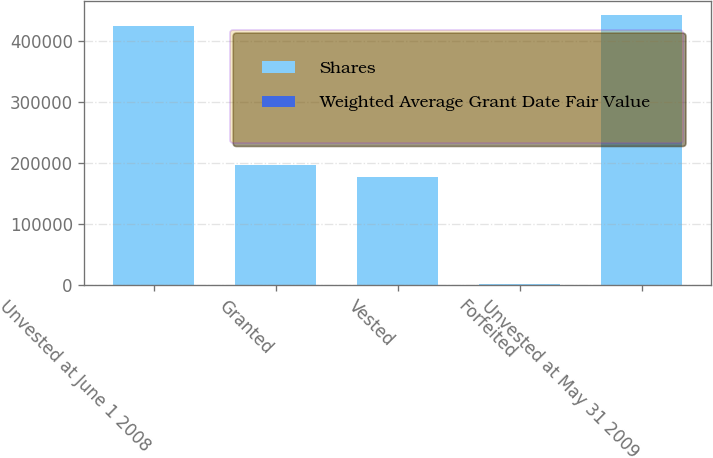<chart> <loc_0><loc_0><loc_500><loc_500><stacked_bar_chart><ecel><fcel>Unvested at June 1 2008<fcel>Granted<fcel>Vested<fcel>Forfeited<fcel>Unvested at May 31 2009<nl><fcel>Shares<fcel>424985<fcel>197180<fcel>177494<fcel>1930<fcel>442741<nl><fcel>Weighted Average Grant Date Fair Value<fcel>103.97<fcel>90.57<fcel>98.05<fcel>100.35<fcel>100.4<nl></chart> 